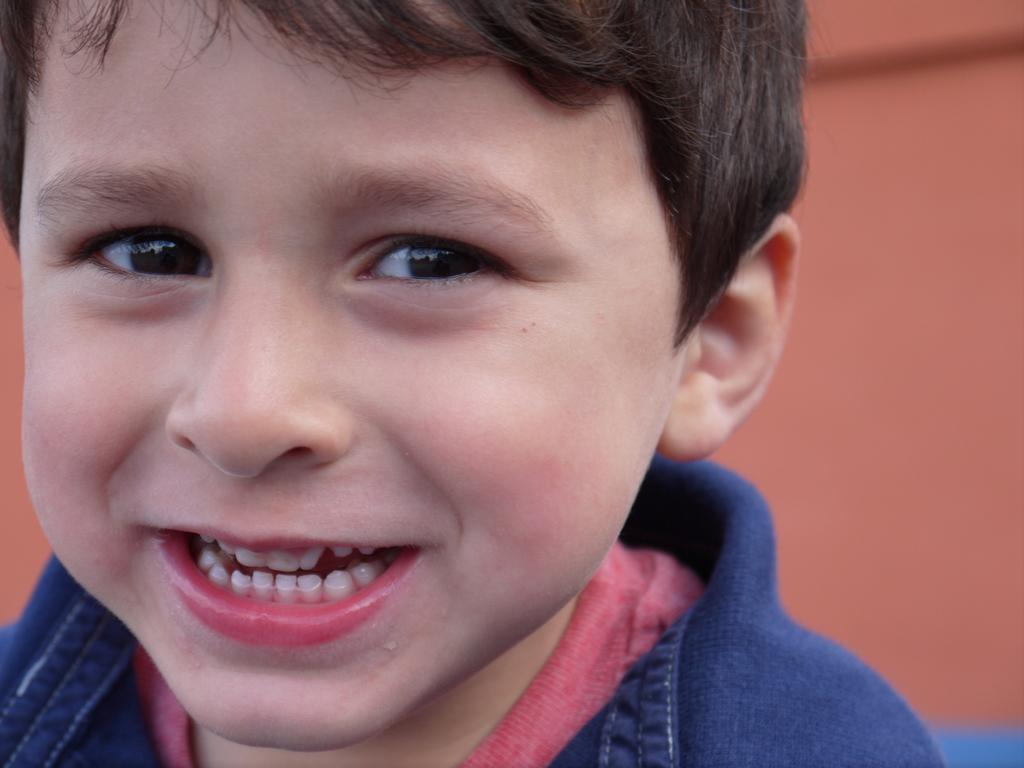What is the main subject of the image? The main subject of the image is a close-up of a child. Where is the child positioned in the image? The child is on the left side of the image. What can be observed about the child's attire? The child is wearing clothes. How would you describe the background of the image? The background is brownish and blurred. What type of wood is being used to balance the toothpaste in the image? There is no wood, balance, or toothpaste present in the image; it features a close-up of a child. 